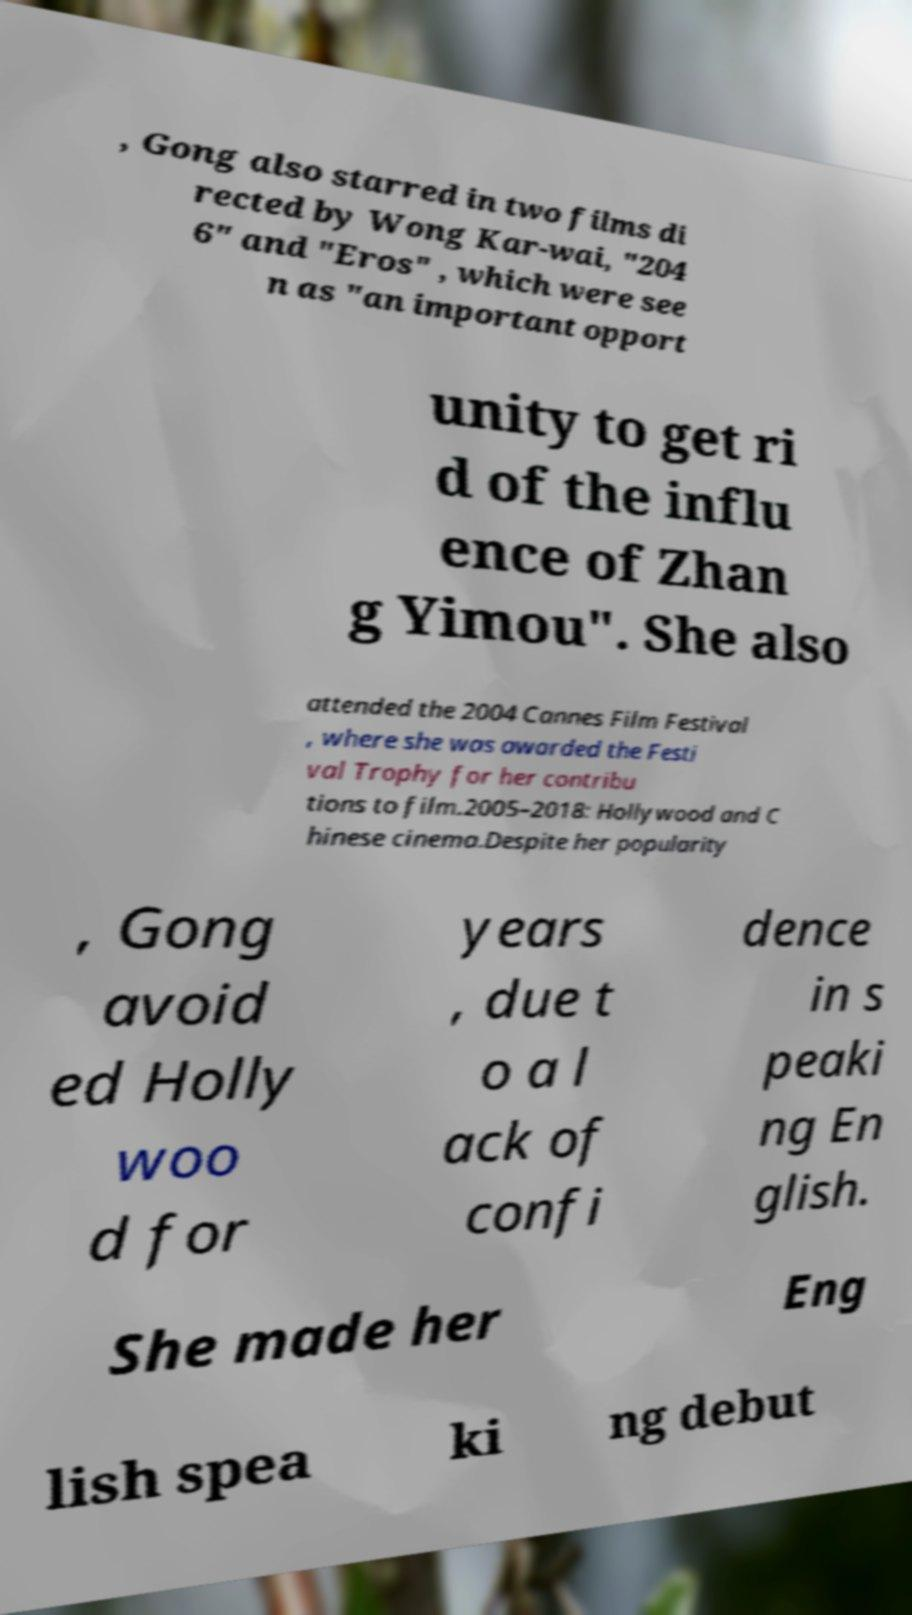What messages or text are displayed in this image? I need them in a readable, typed format. , Gong also starred in two films di rected by Wong Kar-wai, "204 6" and "Eros" , which were see n as "an important opport unity to get ri d of the influ ence of Zhan g Yimou". She also attended the 2004 Cannes Film Festival , where she was awarded the Festi val Trophy for her contribu tions to film.2005–2018: Hollywood and C hinese cinema.Despite her popularity , Gong avoid ed Holly woo d for years , due t o a l ack of confi dence in s peaki ng En glish. She made her Eng lish spea ki ng debut 